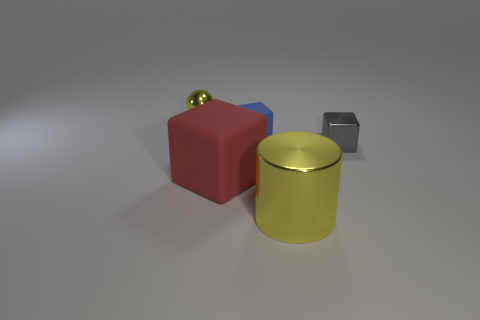Subtract all small blocks. How many blocks are left? 1 Add 5 large red rubber objects. How many objects exist? 10 Subtract all cylinders. How many objects are left? 4 Subtract 0 brown balls. How many objects are left? 5 Subtract all tiny gray metal things. Subtract all red shiny cylinders. How many objects are left? 4 Add 1 red cubes. How many red cubes are left? 2 Add 2 gray things. How many gray things exist? 3 